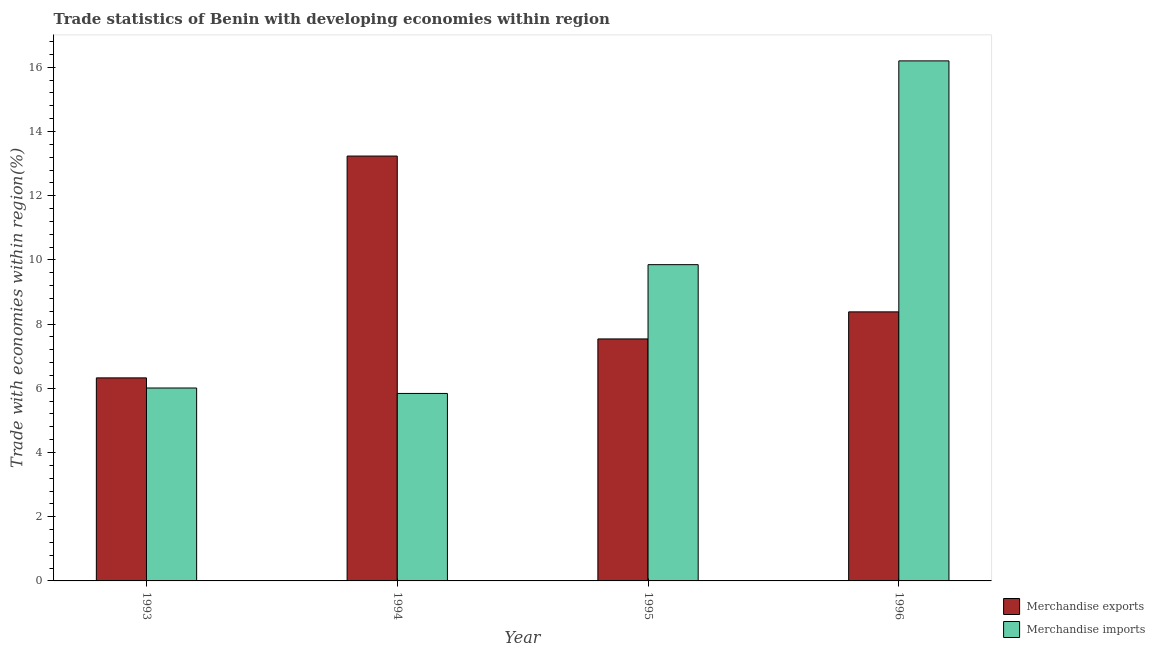How many different coloured bars are there?
Provide a succinct answer. 2. Are the number of bars on each tick of the X-axis equal?
Offer a very short reply. Yes. In how many cases, is the number of bars for a given year not equal to the number of legend labels?
Your response must be concise. 0. What is the merchandise imports in 1995?
Offer a terse response. 9.85. Across all years, what is the maximum merchandise imports?
Your answer should be very brief. 16.2. Across all years, what is the minimum merchandise imports?
Make the answer very short. 5.84. In which year was the merchandise imports minimum?
Give a very brief answer. 1994. What is the total merchandise exports in the graph?
Provide a succinct answer. 35.48. What is the difference between the merchandise imports in 1994 and that in 1996?
Give a very brief answer. -10.36. What is the difference between the merchandise exports in 1993 and the merchandise imports in 1995?
Your response must be concise. -1.21. What is the average merchandise exports per year?
Your answer should be very brief. 8.87. In the year 1994, what is the difference between the merchandise imports and merchandise exports?
Ensure brevity in your answer.  0. What is the ratio of the merchandise exports in 1993 to that in 1996?
Provide a succinct answer. 0.75. Is the merchandise exports in 1995 less than that in 1996?
Provide a succinct answer. Yes. What is the difference between the highest and the second highest merchandise imports?
Offer a very short reply. 6.35. What is the difference between the highest and the lowest merchandise exports?
Keep it short and to the point. 6.91. In how many years, is the merchandise exports greater than the average merchandise exports taken over all years?
Your answer should be compact. 1. Is the sum of the merchandise imports in 1995 and 1996 greater than the maximum merchandise exports across all years?
Your answer should be very brief. Yes. What does the 1st bar from the left in 1994 represents?
Give a very brief answer. Merchandise exports. What does the 2nd bar from the right in 1995 represents?
Your answer should be compact. Merchandise exports. Are all the bars in the graph horizontal?
Offer a terse response. No. How many years are there in the graph?
Give a very brief answer. 4. Does the graph contain any zero values?
Your answer should be compact. No. Does the graph contain grids?
Provide a succinct answer. No. Where does the legend appear in the graph?
Make the answer very short. Bottom right. How many legend labels are there?
Provide a succinct answer. 2. What is the title of the graph?
Provide a succinct answer. Trade statistics of Benin with developing economies within region. Does "Manufacturing industries and construction" appear as one of the legend labels in the graph?
Keep it short and to the point. No. What is the label or title of the X-axis?
Your answer should be compact. Year. What is the label or title of the Y-axis?
Give a very brief answer. Trade with economies within region(%). What is the Trade with economies within region(%) in Merchandise exports in 1993?
Your answer should be compact. 6.33. What is the Trade with economies within region(%) of Merchandise imports in 1993?
Offer a very short reply. 6.01. What is the Trade with economies within region(%) in Merchandise exports in 1994?
Give a very brief answer. 13.24. What is the Trade with economies within region(%) in Merchandise imports in 1994?
Give a very brief answer. 5.84. What is the Trade with economies within region(%) in Merchandise exports in 1995?
Offer a terse response. 7.54. What is the Trade with economies within region(%) of Merchandise imports in 1995?
Offer a terse response. 9.85. What is the Trade with economies within region(%) of Merchandise exports in 1996?
Your response must be concise. 8.38. What is the Trade with economies within region(%) of Merchandise imports in 1996?
Provide a succinct answer. 16.2. Across all years, what is the maximum Trade with economies within region(%) of Merchandise exports?
Keep it short and to the point. 13.24. Across all years, what is the maximum Trade with economies within region(%) of Merchandise imports?
Your answer should be very brief. 16.2. Across all years, what is the minimum Trade with economies within region(%) in Merchandise exports?
Give a very brief answer. 6.33. Across all years, what is the minimum Trade with economies within region(%) of Merchandise imports?
Provide a short and direct response. 5.84. What is the total Trade with economies within region(%) of Merchandise exports in the graph?
Your answer should be compact. 35.48. What is the total Trade with economies within region(%) in Merchandise imports in the graph?
Your answer should be compact. 37.9. What is the difference between the Trade with economies within region(%) of Merchandise exports in 1993 and that in 1994?
Offer a terse response. -6.91. What is the difference between the Trade with economies within region(%) in Merchandise imports in 1993 and that in 1994?
Your answer should be very brief. 0.17. What is the difference between the Trade with economies within region(%) in Merchandise exports in 1993 and that in 1995?
Provide a succinct answer. -1.21. What is the difference between the Trade with economies within region(%) of Merchandise imports in 1993 and that in 1995?
Ensure brevity in your answer.  -3.84. What is the difference between the Trade with economies within region(%) in Merchandise exports in 1993 and that in 1996?
Provide a short and direct response. -2.06. What is the difference between the Trade with economies within region(%) of Merchandise imports in 1993 and that in 1996?
Provide a succinct answer. -10.19. What is the difference between the Trade with economies within region(%) in Merchandise exports in 1994 and that in 1995?
Your answer should be very brief. 5.7. What is the difference between the Trade with economies within region(%) in Merchandise imports in 1994 and that in 1995?
Provide a short and direct response. -4.01. What is the difference between the Trade with economies within region(%) in Merchandise exports in 1994 and that in 1996?
Your response must be concise. 4.85. What is the difference between the Trade with economies within region(%) in Merchandise imports in 1994 and that in 1996?
Make the answer very short. -10.36. What is the difference between the Trade with economies within region(%) of Merchandise exports in 1995 and that in 1996?
Keep it short and to the point. -0.84. What is the difference between the Trade with economies within region(%) in Merchandise imports in 1995 and that in 1996?
Give a very brief answer. -6.35. What is the difference between the Trade with economies within region(%) of Merchandise exports in 1993 and the Trade with economies within region(%) of Merchandise imports in 1994?
Provide a short and direct response. 0.49. What is the difference between the Trade with economies within region(%) of Merchandise exports in 1993 and the Trade with economies within region(%) of Merchandise imports in 1995?
Keep it short and to the point. -3.53. What is the difference between the Trade with economies within region(%) of Merchandise exports in 1993 and the Trade with economies within region(%) of Merchandise imports in 1996?
Offer a terse response. -9.88. What is the difference between the Trade with economies within region(%) of Merchandise exports in 1994 and the Trade with economies within region(%) of Merchandise imports in 1995?
Your answer should be compact. 3.38. What is the difference between the Trade with economies within region(%) of Merchandise exports in 1994 and the Trade with economies within region(%) of Merchandise imports in 1996?
Give a very brief answer. -2.96. What is the difference between the Trade with economies within region(%) in Merchandise exports in 1995 and the Trade with economies within region(%) in Merchandise imports in 1996?
Keep it short and to the point. -8.66. What is the average Trade with economies within region(%) in Merchandise exports per year?
Offer a terse response. 8.87. What is the average Trade with economies within region(%) of Merchandise imports per year?
Provide a succinct answer. 9.48. In the year 1993, what is the difference between the Trade with economies within region(%) in Merchandise exports and Trade with economies within region(%) in Merchandise imports?
Your response must be concise. 0.32. In the year 1994, what is the difference between the Trade with economies within region(%) in Merchandise exports and Trade with economies within region(%) in Merchandise imports?
Your response must be concise. 7.4. In the year 1995, what is the difference between the Trade with economies within region(%) of Merchandise exports and Trade with economies within region(%) of Merchandise imports?
Your response must be concise. -2.31. In the year 1996, what is the difference between the Trade with economies within region(%) of Merchandise exports and Trade with economies within region(%) of Merchandise imports?
Your response must be concise. -7.82. What is the ratio of the Trade with economies within region(%) of Merchandise exports in 1993 to that in 1994?
Your answer should be compact. 0.48. What is the ratio of the Trade with economies within region(%) of Merchandise exports in 1993 to that in 1995?
Make the answer very short. 0.84. What is the ratio of the Trade with economies within region(%) in Merchandise imports in 1993 to that in 1995?
Your answer should be compact. 0.61. What is the ratio of the Trade with economies within region(%) in Merchandise exports in 1993 to that in 1996?
Offer a terse response. 0.75. What is the ratio of the Trade with economies within region(%) in Merchandise imports in 1993 to that in 1996?
Keep it short and to the point. 0.37. What is the ratio of the Trade with economies within region(%) in Merchandise exports in 1994 to that in 1995?
Your answer should be compact. 1.76. What is the ratio of the Trade with economies within region(%) in Merchandise imports in 1994 to that in 1995?
Provide a succinct answer. 0.59. What is the ratio of the Trade with economies within region(%) of Merchandise exports in 1994 to that in 1996?
Give a very brief answer. 1.58. What is the ratio of the Trade with economies within region(%) of Merchandise imports in 1994 to that in 1996?
Give a very brief answer. 0.36. What is the ratio of the Trade with economies within region(%) in Merchandise exports in 1995 to that in 1996?
Offer a very short reply. 0.9. What is the ratio of the Trade with economies within region(%) in Merchandise imports in 1995 to that in 1996?
Ensure brevity in your answer.  0.61. What is the difference between the highest and the second highest Trade with economies within region(%) in Merchandise exports?
Your answer should be very brief. 4.85. What is the difference between the highest and the second highest Trade with economies within region(%) of Merchandise imports?
Provide a succinct answer. 6.35. What is the difference between the highest and the lowest Trade with economies within region(%) in Merchandise exports?
Keep it short and to the point. 6.91. What is the difference between the highest and the lowest Trade with economies within region(%) in Merchandise imports?
Offer a terse response. 10.36. 